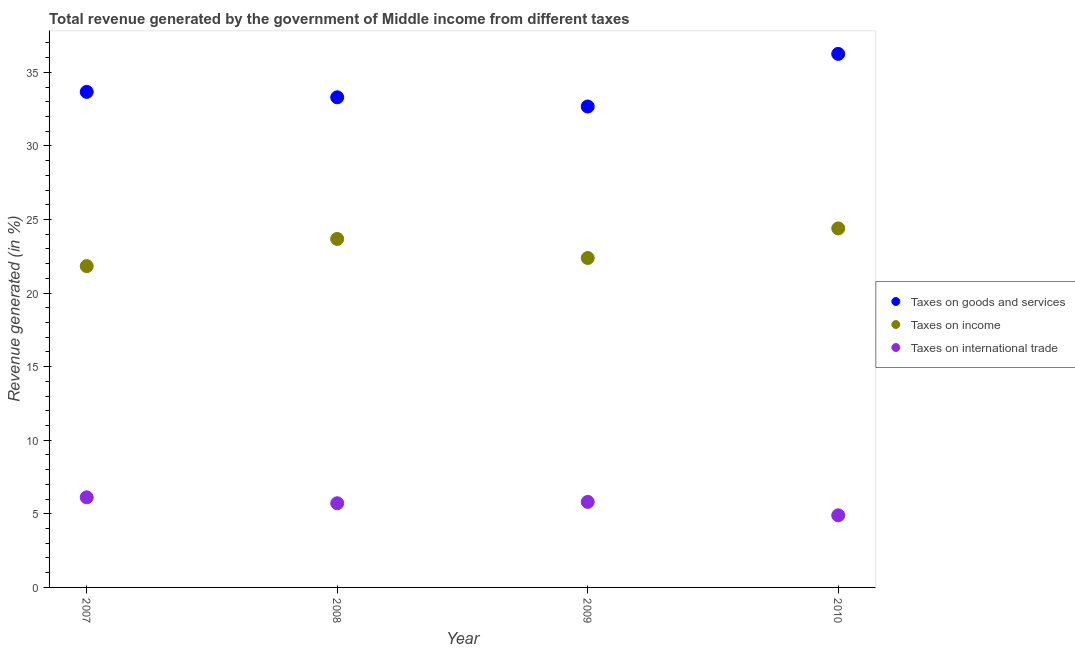How many different coloured dotlines are there?
Your answer should be compact. 3. Is the number of dotlines equal to the number of legend labels?
Your answer should be very brief. Yes. What is the percentage of revenue generated by tax on international trade in 2009?
Offer a very short reply. 5.81. Across all years, what is the maximum percentage of revenue generated by tax on international trade?
Keep it short and to the point. 6.12. Across all years, what is the minimum percentage of revenue generated by taxes on income?
Provide a succinct answer. 21.84. In which year was the percentage of revenue generated by tax on international trade maximum?
Offer a very short reply. 2007. In which year was the percentage of revenue generated by taxes on income minimum?
Ensure brevity in your answer.  2007. What is the total percentage of revenue generated by taxes on income in the graph?
Your answer should be compact. 92.3. What is the difference between the percentage of revenue generated by taxes on income in 2008 and that in 2010?
Provide a short and direct response. -0.72. What is the difference between the percentage of revenue generated by taxes on goods and services in 2008 and the percentage of revenue generated by taxes on income in 2009?
Your answer should be very brief. 10.92. What is the average percentage of revenue generated by taxes on goods and services per year?
Offer a terse response. 33.98. In the year 2007, what is the difference between the percentage of revenue generated by taxes on income and percentage of revenue generated by tax on international trade?
Provide a succinct answer. 15.71. In how many years, is the percentage of revenue generated by taxes on goods and services greater than 33 %?
Provide a short and direct response. 3. What is the ratio of the percentage of revenue generated by taxes on income in 2007 to that in 2008?
Keep it short and to the point. 0.92. Is the percentage of revenue generated by tax on international trade in 2007 less than that in 2008?
Your answer should be very brief. No. What is the difference between the highest and the second highest percentage of revenue generated by taxes on income?
Keep it short and to the point. 0.72. What is the difference between the highest and the lowest percentage of revenue generated by tax on international trade?
Your answer should be compact. 1.22. Is the sum of the percentage of revenue generated by taxes on goods and services in 2007 and 2009 greater than the maximum percentage of revenue generated by taxes on income across all years?
Make the answer very short. Yes. Does the percentage of revenue generated by taxes on goods and services monotonically increase over the years?
Give a very brief answer. No. Is the percentage of revenue generated by taxes on income strictly greater than the percentage of revenue generated by tax on international trade over the years?
Ensure brevity in your answer.  Yes. Is the percentage of revenue generated by tax on international trade strictly less than the percentage of revenue generated by taxes on income over the years?
Your response must be concise. Yes. What is the difference between two consecutive major ticks on the Y-axis?
Offer a very short reply. 5. Where does the legend appear in the graph?
Give a very brief answer. Center right. How many legend labels are there?
Make the answer very short. 3. How are the legend labels stacked?
Your answer should be compact. Vertical. What is the title of the graph?
Keep it short and to the point. Total revenue generated by the government of Middle income from different taxes. Does "Resident buildings and public services" appear as one of the legend labels in the graph?
Your response must be concise. No. What is the label or title of the Y-axis?
Keep it short and to the point. Revenue generated (in %). What is the Revenue generated (in %) of Taxes on goods and services in 2007?
Your answer should be compact. 33.68. What is the Revenue generated (in %) in Taxes on income in 2007?
Offer a terse response. 21.84. What is the Revenue generated (in %) in Taxes on international trade in 2007?
Give a very brief answer. 6.12. What is the Revenue generated (in %) in Taxes on goods and services in 2008?
Provide a succinct answer. 33.31. What is the Revenue generated (in %) of Taxes on income in 2008?
Offer a terse response. 23.68. What is the Revenue generated (in %) in Taxes on international trade in 2008?
Offer a terse response. 5.72. What is the Revenue generated (in %) in Taxes on goods and services in 2009?
Your answer should be very brief. 32.68. What is the Revenue generated (in %) of Taxes on income in 2009?
Keep it short and to the point. 22.39. What is the Revenue generated (in %) in Taxes on international trade in 2009?
Offer a terse response. 5.81. What is the Revenue generated (in %) in Taxes on goods and services in 2010?
Provide a short and direct response. 36.26. What is the Revenue generated (in %) of Taxes on income in 2010?
Make the answer very short. 24.4. What is the Revenue generated (in %) of Taxes on international trade in 2010?
Offer a very short reply. 4.9. Across all years, what is the maximum Revenue generated (in %) of Taxes on goods and services?
Provide a short and direct response. 36.26. Across all years, what is the maximum Revenue generated (in %) in Taxes on income?
Your response must be concise. 24.4. Across all years, what is the maximum Revenue generated (in %) of Taxes on international trade?
Provide a short and direct response. 6.12. Across all years, what is the minimum Revenue generated (in %) of Taxes on goods and services?
Offer a terse response. 32.68. Across all years, what is the minimum Revenue generated (in %) of Taxes on income?
Your response must be concise. 21.84. Across all years, what is the minimum Revenue generated (in %) of Taxes on international trade?
Offer a very short reply. 4.9. What is the total Revenue generated (in %) in Taxes on goods and services in the graph?
Offer a very short reply. 135.92. What is the total Revenue generated (in %) in Taxes on income in the graph?
Keep it short and to the point. 92.3. What is the total Revenue generated (in %) in Taxes on international trade in the graph?
Give a very brief answer. 22.55. What is the difference between the Revenue generated (in %) in Taxes on goods and services in 2007 and that in 2008?
Your answer should be compact. 0.37. What is the difference between the Revenue generated (in %) of Taxes on income in 2007 and that in 2008?
Make the answer very short. -1.85. What is the difference between the Revenue generated (in %) in Taxes on international trade in 2007 and that in 2008?
Give a very brief answer. 0.4. What is the difference between the Revenue generated (in %) in Taxes on goods and services in 2007 and that in 2009?
Make the answer very short. 0.99. What is the difference between the Revenue generated (in %) of Taxes on income in 2007 and that in 2009?
Your answer should be compact. -0.55. What is the difference between the Revenue generated (in %) in Taxes on international trade in 2007 and that in 2009?
Give a very brief answer. 0.31. What is the difference between the Revenue generated (in %) in Taxes on goods and services in 2007 and that in 2010?
Provide a succinct answer. -2.58. What is the difference between the Revenue generated (in %) in Taxes on income in 2007 and that in 2010?
Provide a short and direct response. -2.56. What is the difference between the Revenue generated (in %) in Taxes on international trade in 2007 and that in 2010?
Give a very brief answer. 1.22. What is the difference between the Revenue generated (in %) of Taxes on goods and services in 2008 and that in 2009?
Offer a very short reply. 0.63. What is the difference between the Revenue generated (in %) in Taxes on income in 2008 and that in 2009?
Offer a terse response. 1.3. What is the difference between the Revenue generated (in %) in Taxes on international trade in 2008 and that in 2009?
Give a very brief answer. -0.09. What is the difference between the Revenue generated (in %) in Taxes on goods and services in 2008 and that in 2010?
Your answer should be very brief. -2.95. What is the difference between the Revenue generated (in %) of Taxes on income in 2008 and that in 2010?
Your response must be concise. -0.72. What is the difference between the Revenue generated (in %) of Taxes on international trade in 2008 and that in 2010?
Ensure brevity in your answer.  0.82. What is the difference between the Revenue generated (in %) in Taxes on goods and services in 2009 and that in 2010?
Your response must be concise. -3.58. What is the difference between the Revenue generated (in %) of Taxes on income in 2009 and that in 2010?
Give a very brief answer. -2.01. What is the difference between the Revenue generated (in %) in Taxes on international trade in 2009 and that in 2010?
Provide a succinct answer. 0.91. What is the difference between the Revenue generated (in %) of Taxes on goods and services in 2007 and the Revenue generated (in %) of Taxes on income in 2008?
Your answer should be compact. 9.99. What is the difference between the Revenue generated (in %) of Taxes on goods and services in 2007 and the Revenue generated (in %) of Taxes on international trade in 2008?
Your answer should be compact. 27.96. What is the difference between the Revenue generated (in %) in Taxes on income in 2007 and the Revenue generated (in %) in Taxes on international trade in 2008?
Ensure brevity in your answer.  16.12. What is the difference between the Revenue generated (in %) in Taxes on goods and services in 2007 and the Revenue generated (in %) in Taxes on income in 2009?
Give a very brief answer. 11.29. What is the difference between the Revenue generated (in %) of Taxes on goods and services in 2007 and the Revenue generated (in %) of Taxes on international trade in 2009?
Offer a very short reply. 27.86. What is the difference between the Revenue generated (in %) in Taxes on income in 2007 and the Revenue generated (in %) in Taxes on international trade in 2009?
Make the answer very short. 16.02. What is the difference between the Revenue generated (in %) of Taxes on goods and services in 2007 and the Revenue generated (in %) of Taxes on income in 2010?
Give a very brief answer. 9.28. What is the difference between the Revenue generated (in %) of Taxes on goods and services in 2007 and the Revenue generated (in %) of Taxes on international trade in 2010?
Your answer should be very brief. 28.78. What is the difference between the Revenue generated (in %) of Taxes on income in 2007 and the Revenue generated (in %) of Taxes on international trade in 2010?
Your response must be concise. 16.94. What is the difference between the Revenue generated (in %) in Taxes on goods and services in 2008 and the Revenue generated (in %) in Taxes on income in 2009?
Provide a succinct answer. 10.92. What is the difference between the Revenue generated (in %) of Taxes on goods and services in 2008 and the Revenue generated (in %) of Taxes on international trade in 2009?
Your answer should be very brief. 27.5. What is the difference between the Revenue generated (in %) of Taxes on income in 2008 and the Revenue generated (in %) of Taxes on international trade in 2009?
Provide a succinct answer. 17.87. What is the difference between the Revenue generated (in %) of Taxes on goods and services in 2008 and the Revenue generated (in %) of Taxes on income in 2010?
Your answer should be compact. 8.91. What is the difference between the Revenue generated (in %) in Taxes on goods and services in 2008 and the Revenue generated (in %) in Taxes on international trade in 2010?
Keep it short and to the point. 28.41. What is the difference between the Revenue generated (in %) in Taxes on income in 2008 and the Revenue generated (in %) in Taxes on international trade in 2010?
Make the answer very short. 18.78. What is the difference between the Revenue generated (in %) of Taxes on goods and services in 2009 and the Revenue generated (in %) of Taxes on income in 2010?
Offer a terse response. 8.28. What is the difference between the Revenue generated (in %) in Taxes on goods and services in 2009 and the Revenue generated (in %) in Taxes on international trade in 2010?
Your answer should be very brief. 27.78. What is the difference between the Revenue generated (in %) in Taxes on income in 2009 and the Revenue generated (in %) in Taxes on international trade in 2010?
Give a very brief answer. 17.49. What is the average Revenue generated (in %) in Taxes on goods and services per year?
Provide a succinct answer. 33.98. What is the average Revenue generated (in %) of Taxes on income per year?
Provide a short and direct response. 23.08. What is the average Revenue generated (in %) of Taxes on international trade per year?
Provide a short and direct response. 5.64. In the year 2007, what is the difference between the Revenue generated (in %) of Taxes on goods and services and Revenue generated (in %) of Taxes on income?
Your answer should be compact. 11.84. In the year 2007, what is the difference between the Revenue generated (in %) of Taxes on goods and services and Revenue generated (in %) of Taxes on international trade?
Your answer should be compact. 27.55. In the year 2007, what is the difference between the Revenue generated (in %) in Taxes on income and Revenue generated (in %) in Taxes on international trade?
Make the answer very short. 15.71. In the year 2008, what is the difference between the Revenue generated (in %) in Taxes on goods and services and Revenue generated (in %) in Taxes on income?
Offer a terse response. 9.62. In the year 2008, what is the difference between the Revenue generated (in %) of Taxes on goods and services and Revenue generated (in %) of Taxes on international trade?
Provide a short and direct response. 27.59. In the year 2008, what is the difference between the Revenue generated (in %) of Taxes on income and Revenue generated (in %) of Taxes on international trade?
Offer a very short reply. 17.96. In the year 2009, what is the difference between the Revenue generated (in %) in Taxes on goods and services and Revenue generated (in %) in Taxes on income?
Offer a terse response. 10.29. In the year 2009, what is the difference between the Revenue generated (in %) of Taxes on goods and services and Revenue generated (in %) of Taxes on international trade?
Provide a succinct answer. 26.87. In the year 2009, what is the difference between the Revenue generated (in %) in Taxes on income and Revenue generated (in %) in Taxes on international trade?
Ensure brevity in your answer.  16.58. In the year 2010, what is the difference between the Revenue generated (in %) of Taxes on goods and services and Revenue generated (in %) of Taxes on income?
Your answer should be very brief. 11.86. In the year 2010, what is the difference between the Revenue generated (in %) of Taxes on goods and services and Revenue generated (in %) of Taxes on international trade?
Your response must be concise. 31.36. In the year 2010, what is the difference between the Revenue generated (in %) in Taxes on income and Revenue generated (in %) in Taxes on international trade?
Keep it short and to the point. 19.5. What is the ratio of the Revenue generated (in %) of Taxes on goods and services in 2007 to that in 2008?
Your response must be concise. 1.01. What is the ratio of the Revenue generated (in %) of Taxes on income in 2007 to that in 2008?
Make the answer very short. 0.92. What is the ratio of the Revenue generated (in %) of Taxes on international trade in 2007 to that in 2008?
Your response must be concise. 1.07. What is the ratio of the Revenue generated (in %) in Taxes on goods and services in 2007 to that in 2009?
Provide a short and direct response. 1.03. What is the ratio of the Revenue generated (in %) in Taxes on income in 2007 to that in 2009?
Offer a terse response. 0.98. What is the ratio of the Revenue generated (in %) in Taxes on international trade in 2007 to that in 2009?
Offer a terse response. 1.05. What is the ratio of the Revenue generated (in %) of Taxes on goods and services in 2007 to that in 2010?
Offer a terse response. 0.93. What is the ratio of the Revenue generated (in %) in Taxes on income in 2007 to that in 2010?
Provide a succinct answer. 0.89. What is the ratio of the Revenue generated (in %) in Taxes on international trade in 2007 to that in 2010?
Offer a very short reply. 1.25. What is the ratio of the Revenue generated (in %) in Taxes on goods and services in 2008 to that in 2009?
Offer a terse response. 1.02. What is the ratio of the Revenue generated (in %) of Taxes on income in 2008 to that in 2009?
Ensure brevity in your answer.  1.06. What is the ratio of the Revenue generated (in %) in Taxes on international trade in 2008 to that in 2009?
Provide a short and direct response. 0.98. What is the ratio of the Revenue generated (in %) of Taxes on goods and services in 2008 to that in 2010?
Ensure brevity in your answer.  0.92. What is the ratio of the Revenue generated (in %) of Taxes on income in 2008 to that in 2010?
Make the answer very short. 0.97. What is the ratio of the Revenue generated (in %) of Taxes on international trade in 2008 to that in 2010?
Provide a short and direct response. 1.17. What is the ratio of the Revenue generated (in %) in Taxes on goods and services in 2009 to that in 2010?
Your answer should be very brief. 0.9. What is the ratio of the Revenue generated (in %) in Taxes on income in 2009 to that in 2010?
Your answer should be compact. 0.92. What is the ratio of the Revenue generated (in %) of Taxes on international trade in 2009 to that in 2010?
Your answer should be compact. 1.19. What is the difference between the highest and the second highest Revenue generated (in %) of Taxes on goods and services?
Offer a terse response. 2.58. What is the difference between the highest and the second highest Revenue generated (in %) of Taxes on income?
Your answer should be compact. 0.72. What is the difference between the highest and the second highest Revenue generated (in %) in Taxes on international trade?
Ensure brevity in your answer.  0.31. What is the difference between the highest and the lowest Revenue generated (in %) of Taxes on goods and services?
Provide a succinct answer. 3.58. What is the difference between the highest and the lowest Revenue generated (in %) in Taxes on income?
Provide a short and direct response. 2.56. What is the difference between the highest and the lowest Revenue generated (in %) in Taxes on international trade?
Your answer should be compact. 1.22. 